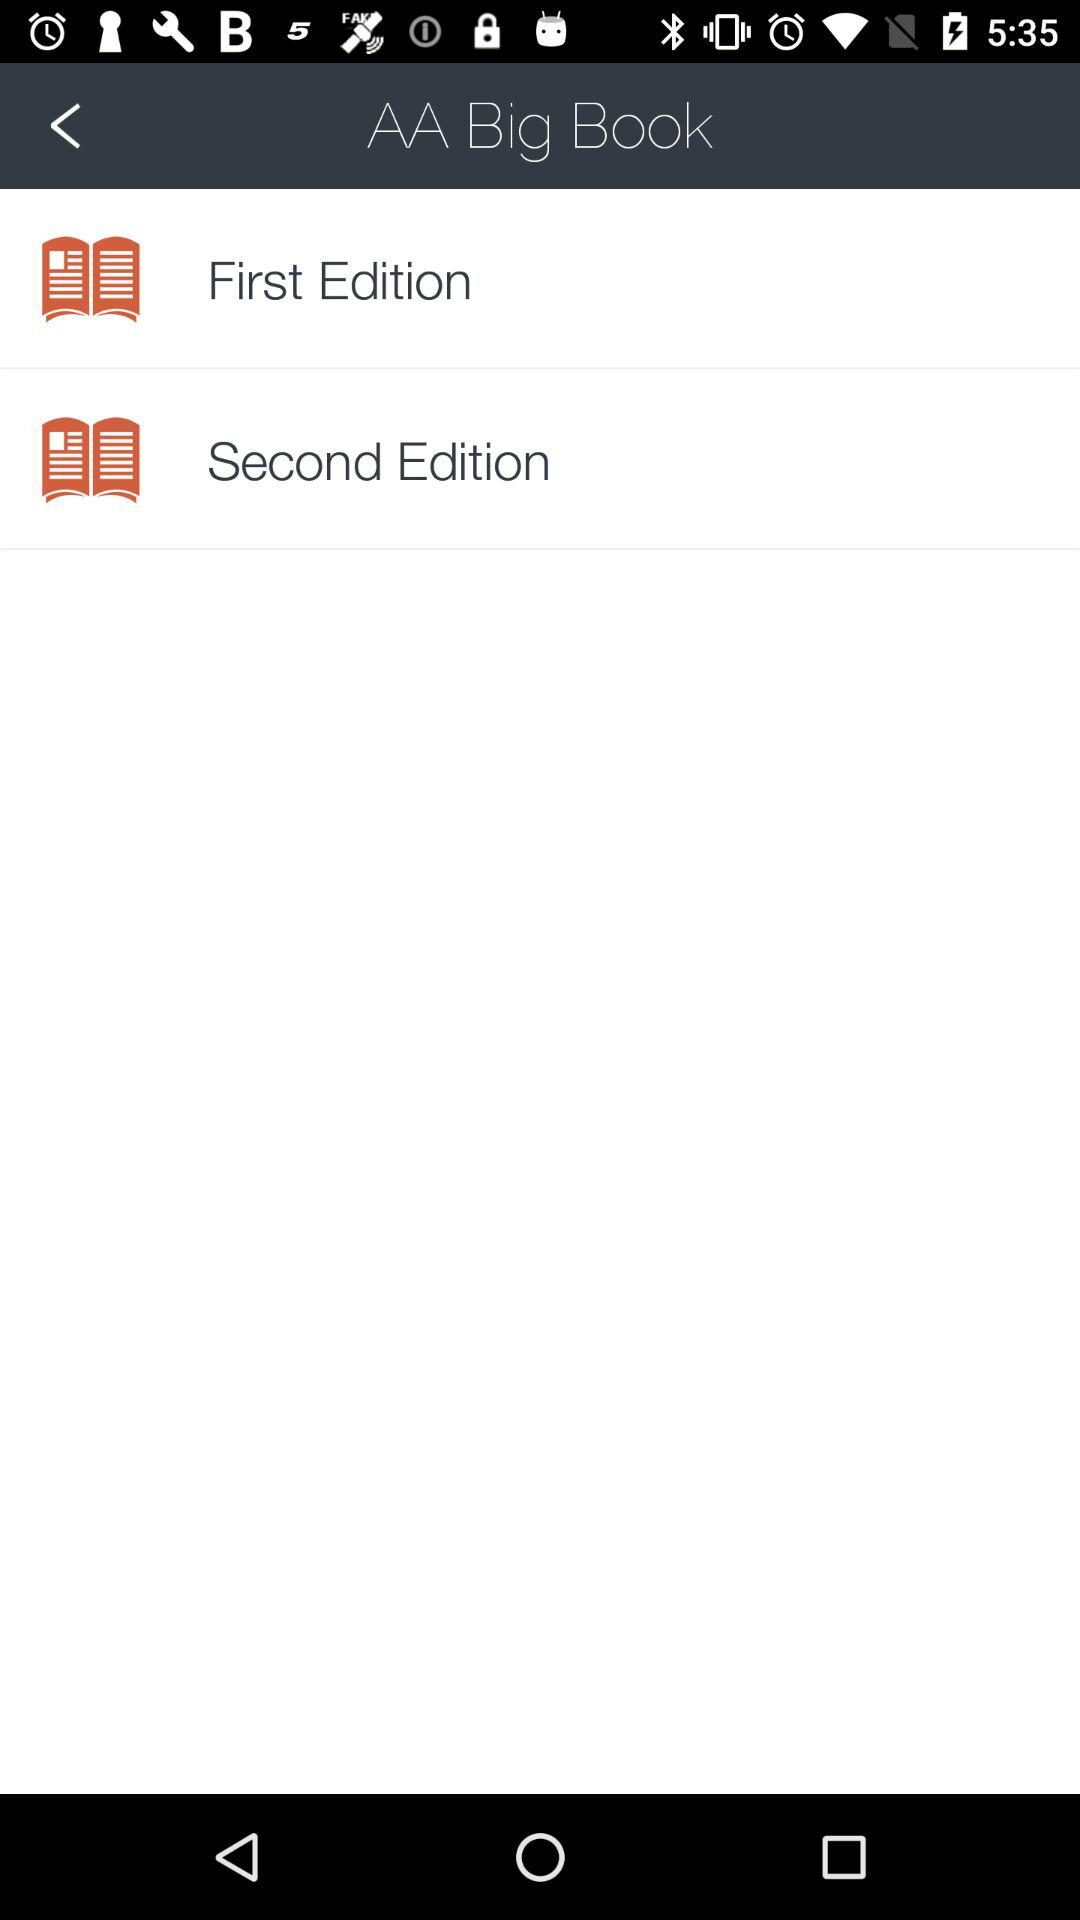How many editions of the book are there?
Answer the question using a single word or phrase. 2 